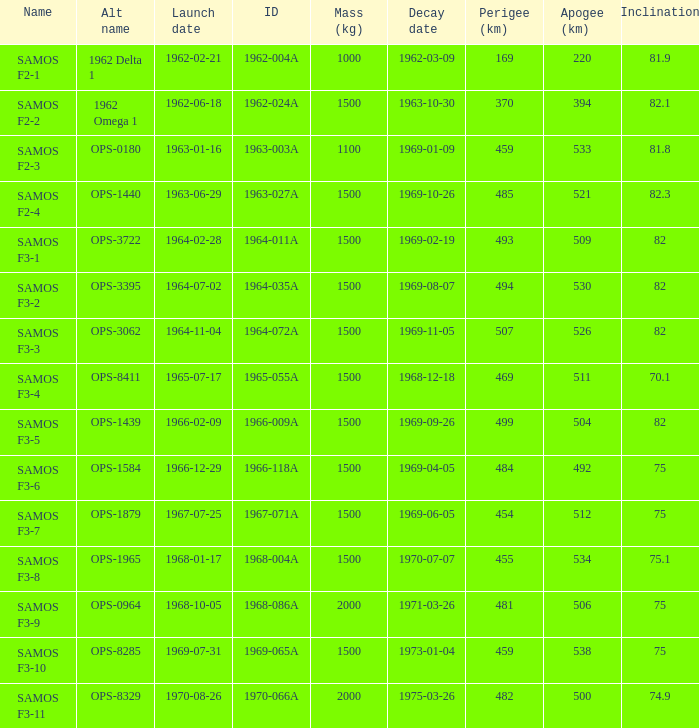What is the highest apogee achievable by samos f3-3? 526.0. 